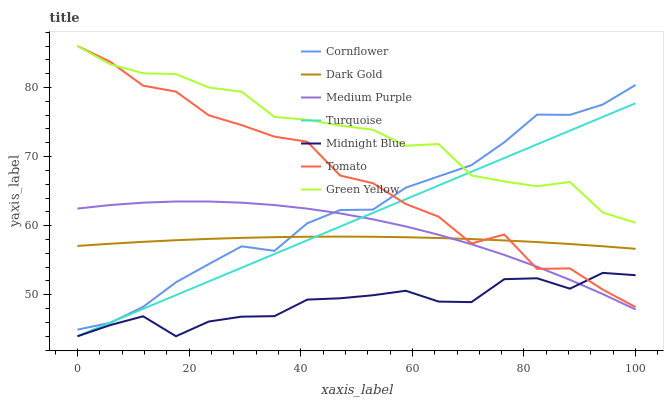Does Midnight Blue have the minimum area under the curve?
Answer yes or no. Yes. Does Green Yellow have the maximum area under the curve?
Answer yes or no. Yes. Does Cornflower have the minimum area under the curve?
Answer yes or no. No. Does Cornflower have the maximum area under the curve?
Answer yes or no. No. Is Turquoise the smoothest?
Answer yes or no. Yes. Is Tomato the roughest?
Answer yes or no. Yes. Is Cornflower the smoothest?
Answer yes or no. No. Is Cornflower the roughest?
Answer yes or no. No. Does Turquoise have the lowest value?
Answer yes or no. Yes. Does Cornflower have the lowest value?
Answer yes or no. No. Does Green Yellow have the highest value?
Answer yes or no. Yes. Does Cornflower have the highest value?
Answer yes or no. No. Is Midnight Blue less than Green Yellow?
Answer yes or no. Yes. Is Green Yellow greater than Midnight Blue?
Answer yes or no. Yes. Does Cornflower intersect Tomato?
Answer yes or no. Yes. Is Cornflower less than Tomato?
Answer yes or no. No. Is Cornflower greater than Tomato?
Answer yes or no. No. Does Midnight Blue intersect Green Yellow?
Answer yes or no. No. 